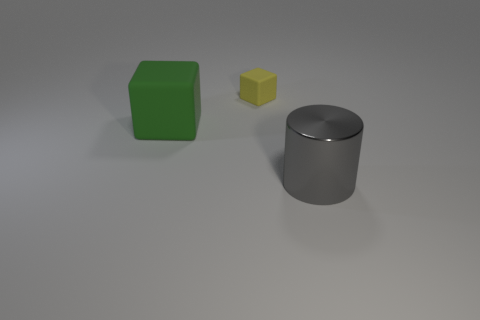Add 3 big matte cubes. How many objects exist? 6 Subtract all cubes. How many objects are left? 1 Subtract 0 red cylinders. How many objects are left? 3 Subtract all blue blocks. Subtract all yellow cylinders. How many blocks are left? 2 Subtract all big gray objects. Subtract all gray shiny things. How many objects are left? 1 Add 2 large metal cylinders. How many large metal cylinders are left? 3 Add 3 large red cylinders. How many large red cylinders exist? 3 